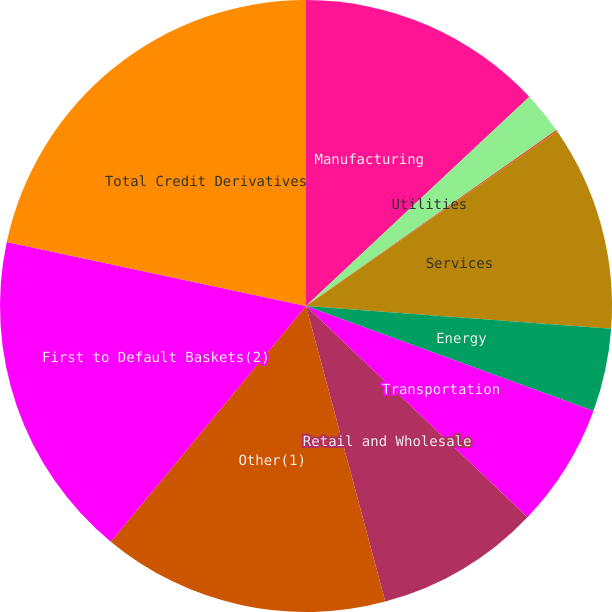Convert chart to OTSL. <chart><loc_0><loc_0><loc_500><loc_500><pie_chart><fcel>Manufacturing<fcel>Utilities<fcel>Finance<fcel>Services<fcel>Energy<fcel>Transportation<fcel>Retail and Wholesale<fcel>Other(1)<fcel>First to Default Baskets(2)<fcel>Total Credit Derivatives<nl><fcel>13.02%<fcel>2.23%<fcel>0.07%<fcel>10.86%<fcel>4.39%<fcel>6.55%<fcel>8.71%<fcel>15.18%<fcel>17.34%<fcel>21.65%<nl></chart> 